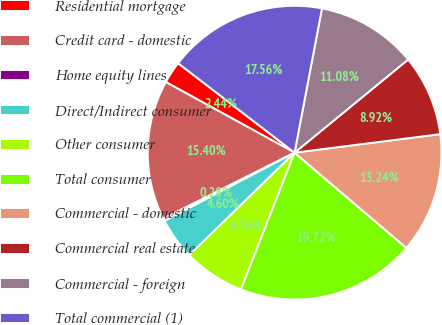Convert chart. <chart><loc_0><loc_0><loc_500><loc_500><pie_chart><fcel>Residential mortgage<fcel>Credit card - domestic<fcel>Home equity lines<fcel>Direct/Indirect consumer<fcel>Other consumer<fcel>Total consumer<fcel>Commercial - domestic<fcel>Commercial real estate<fcel>Commercial - foreign<fcel>Total commercial (1)<nl><fcel>2.44%<fcel>15.4%<fcel>0.28%<fcel>4.6%<fcel>6.76%<fcel>19.72%<fcel>13.24%<fcel>8.92%<fcel>11.08%<fcel>17.56%<nl></chart> 